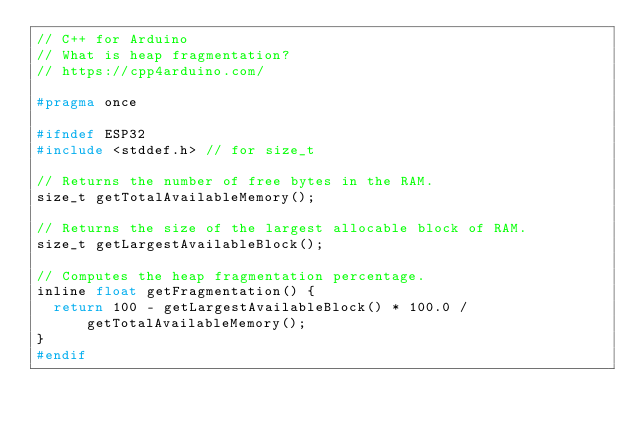<code> <loc_0><loc_0><loc_500><loc_500><_C_>// C++ for Arduino
// What is heap fragmentation?
// https://cpp4arduino.com/

#pragma once

#ifndef ESP32
#include <stddef.h> // for size_t

// Returns the number of free bytes in the RAM.
size_t getTotalAvailableMemory();

// Returns the size of the largest allocable block of RAM.
size_t getLargestAvailableBlock();

// Computes the heap fragmentation percentage.
inline float getFragmentation() {
  return 100 - getLargestAvailableBlock() * 100.0 / getTotalAvailableMemory();
}
#endif</code> 